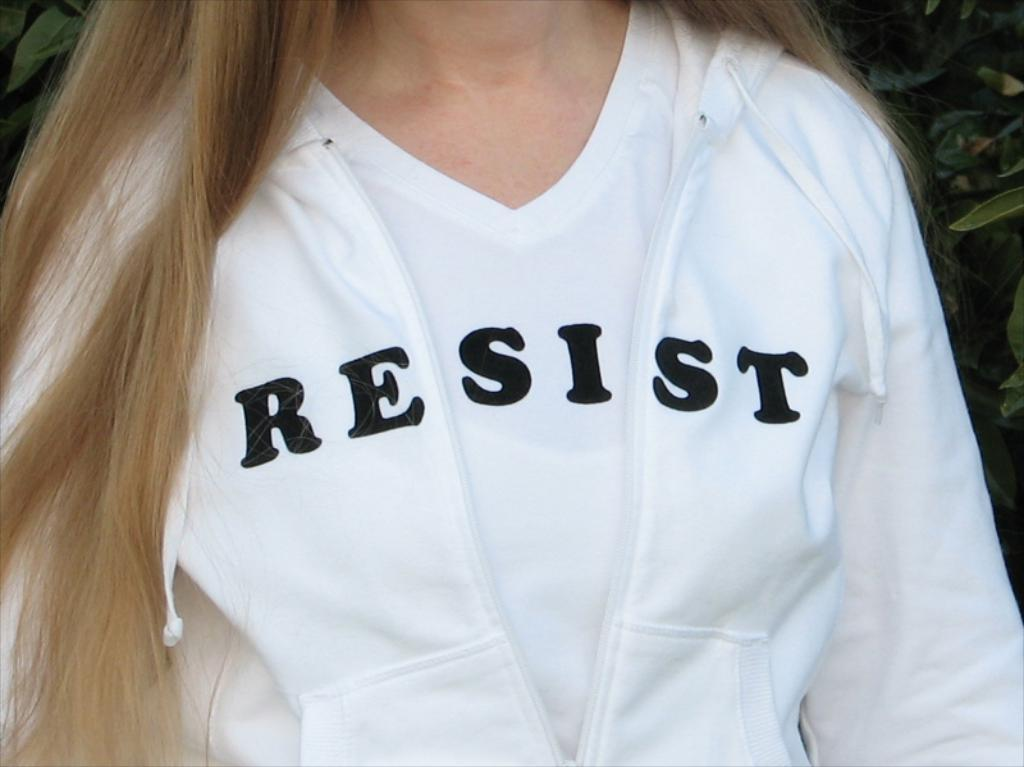<image>
Share a concise interpretation of the image provided. Women wearing a white sweater with the word RESIST written on it. 